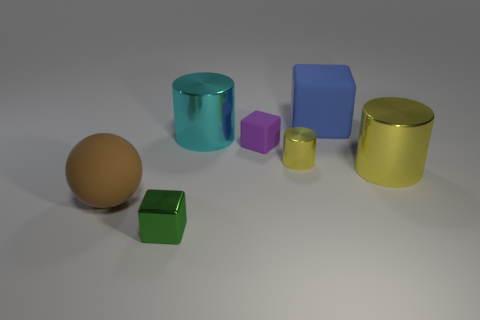Subtract all matte cubes. How many cubes are left? 1 Subtract all cyan cylinders. How many cylinders are left? 2 Subtract 1 blocks. How many blocks are left? 2 Subtract all yellow spheres. How many purple cubes are left? 1 Subtract all balls. How many objects are left? 6 Subtract all brown cylinders. Subtract all blue balls. How many cylinders are left? 3 Subtract all blue blocks. Subtract all large blue shiny blocks. How many objects are left? 6 Add 6 tiny matte cubes. How many tiny matte cubes are left? 7 Add 7 green rubber spheres. How many green rubber spheres exist? 7 Add 2 blue rubber balls. How many objects exist? 9 